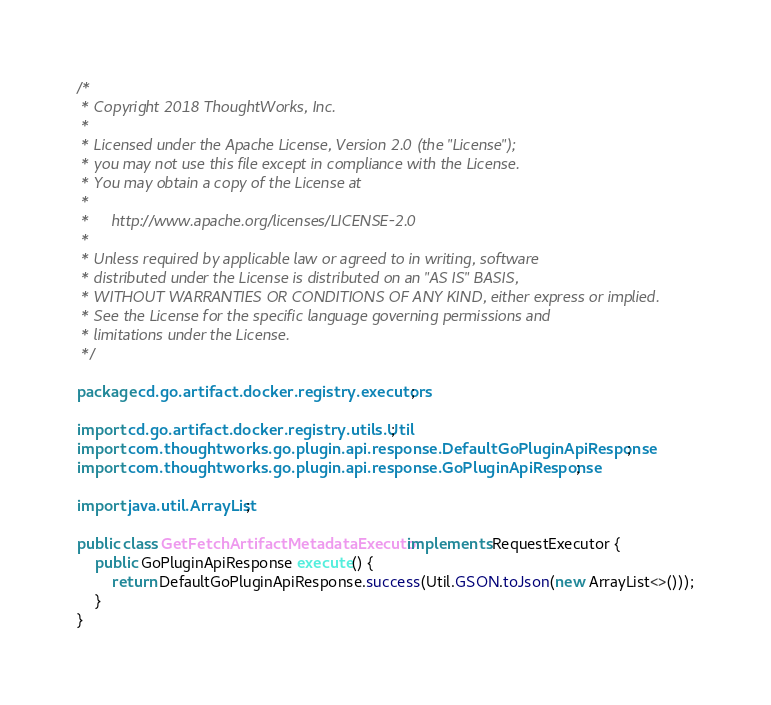<code> <loc_0><loc_0><loc_500><loc_500><_Java_>/*
 * Copyright 2018 ThoughtWorks, Inc.
 *
 * Licensed under the Apache License, Version 2.0 (the "License");
 * you may not use this file except in compliance with the License.
 * You may obtain a copy of the License at
 *
 *     http://www.apache.org/licenses/LICENSE-2.0
 *
 * Unless required by applicable law or agreed to in writing, software
 * distributed under the License is distributed on an "AS IS" BASIS,
 * WITHOUT WARRANTIES OR CONDITIONS OF ANY KIND, either express or implied.
 * See the License for the specific language governing permissions and
 * limitations under the License.
 */

package cd.go.artifact.docker.registry.executors;

import cd.go.artifact.docker.registry.utils.Util;
import com.thoughtworks.go.plugin.api.response.DefaultGoPluginApiResponse;
import com.thoughtworks.go.plugin.api.response.GoPluginApiResponse;

import java.util.ArrayList;

public class GetFetchArtifactMetadataExecutor implements RequestExecutor {
    public GoPluginApiResponse execute() {
        return DefaultGoPluginApiResponse.success(Util.GSON.toJson(new ArrayList<>()));
    }
}

</code> 